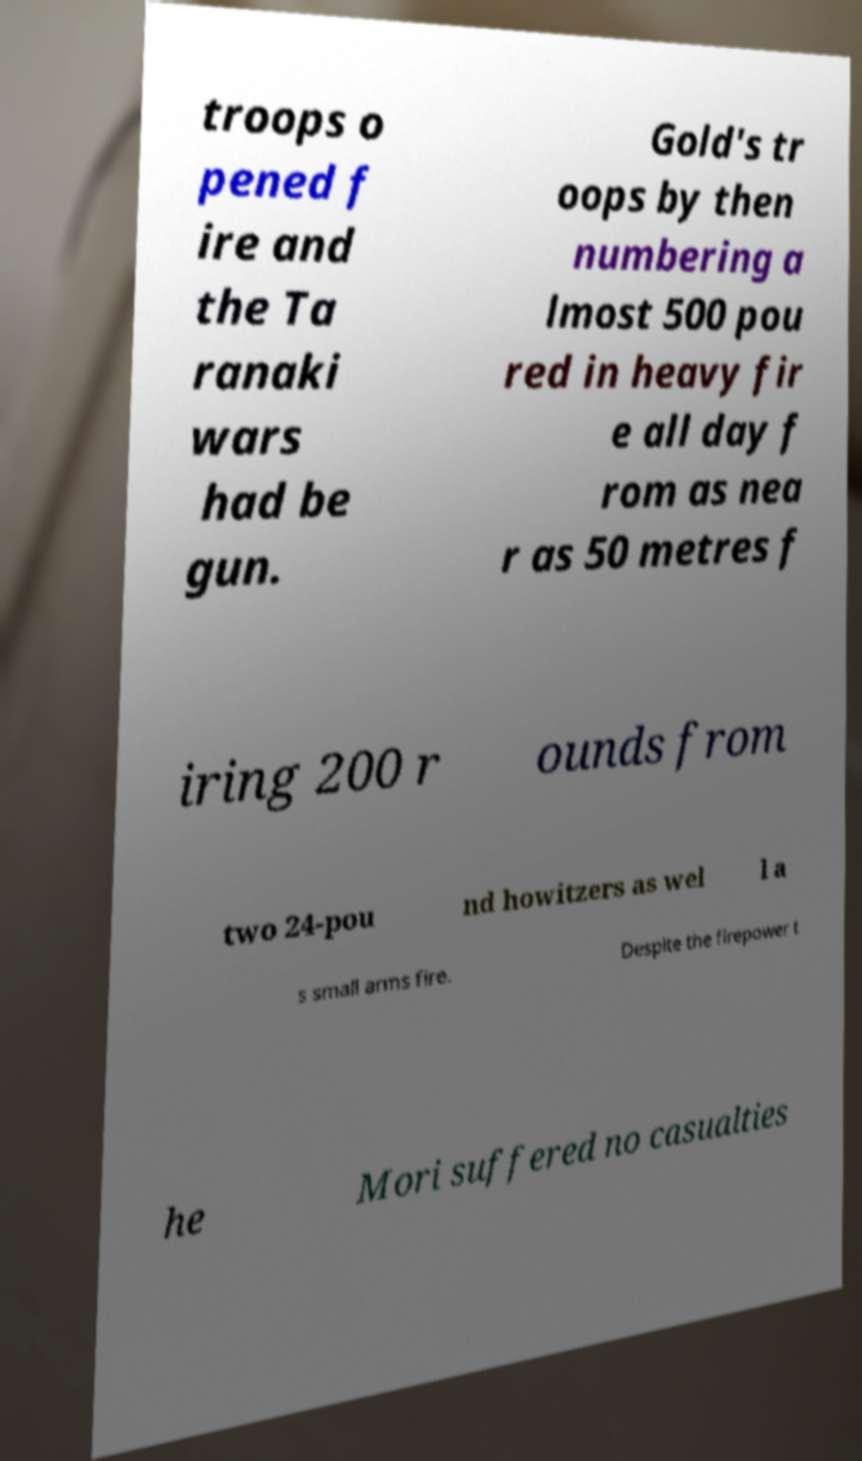For documentation purposes, I need the text within this image transcribed. Could you provide that? troops o pened f ire and the Ta ranaki wars had be gun. Gold's tr oops by then numbering a lmost 500 pou red in heavy fir e all day f rom as nea r as 50 metres f iring 200 r ounds from two 24-pou nd howitzers as wel l a s small arms fire. Despite the firepower t he Mori suffered no casualties 